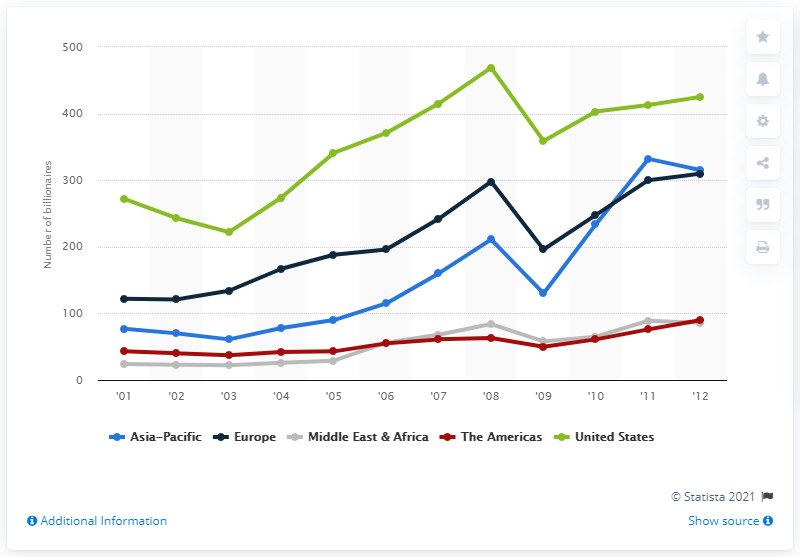Indicate a few pertinent items in this graphic. In 2001, there were 77 billionaires in the Asia-Pacific region. In 2012, there were 310 billionaires in the Asia-Pacific region. 